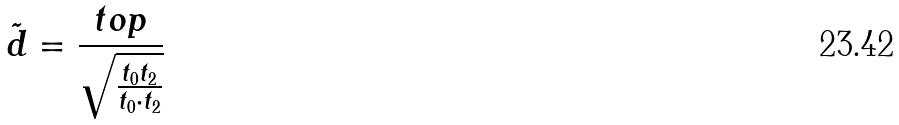<formula> <loc_0><loc_0><loc_500><loc_500>\tilde { d } = \frac { t o p } { \sqrt { \frac { t _ { 0 } t _ { 2 } } { t _ { 0 } \cdot t _ { 2 } } } }</formula> 